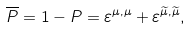<formula> <loc_0><loc_0><loc_500><loc_500>\overline { P } = 1 - P = \varepsilon ^ { \mu , \mu } + \varepsilon ^ { \widetilde { \mu } , \widetilde { \mu } } ,</formula> 